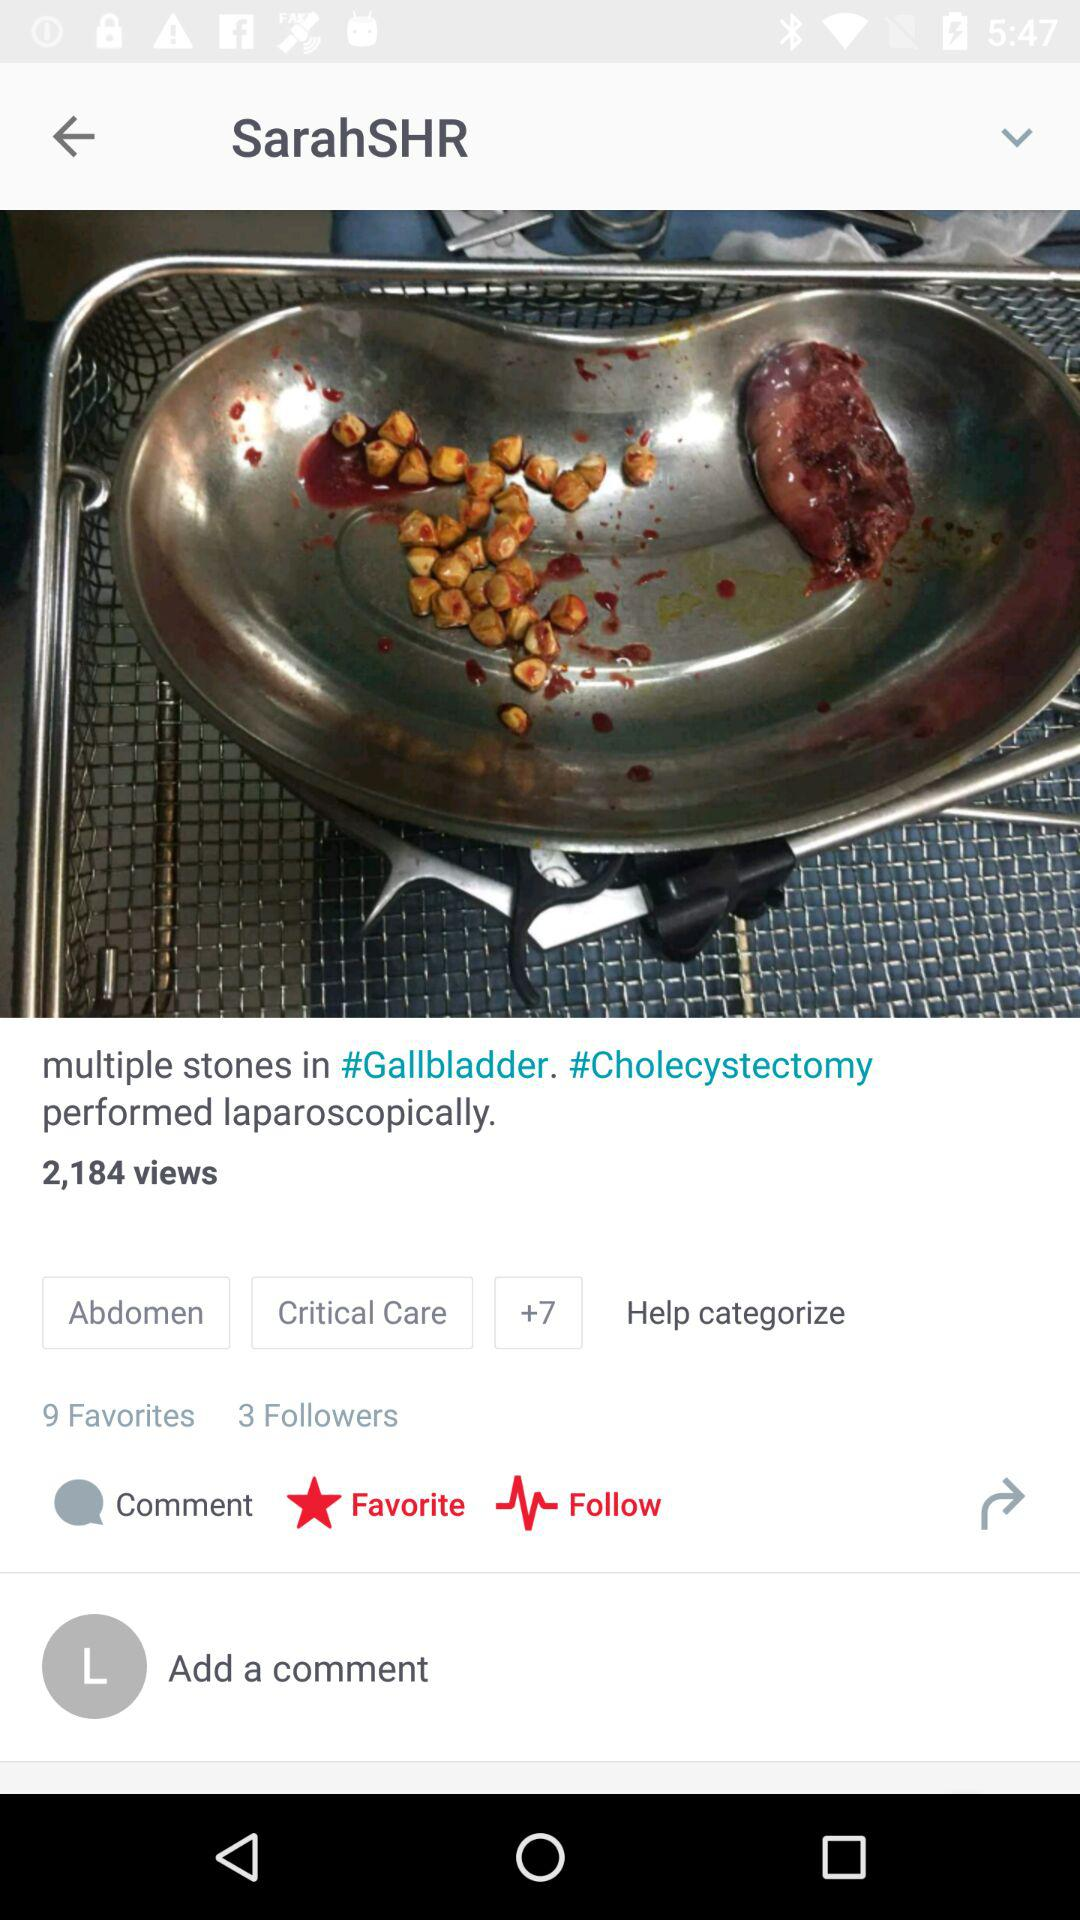What is the email address? The email address is appcrawler1@gmail.com. 